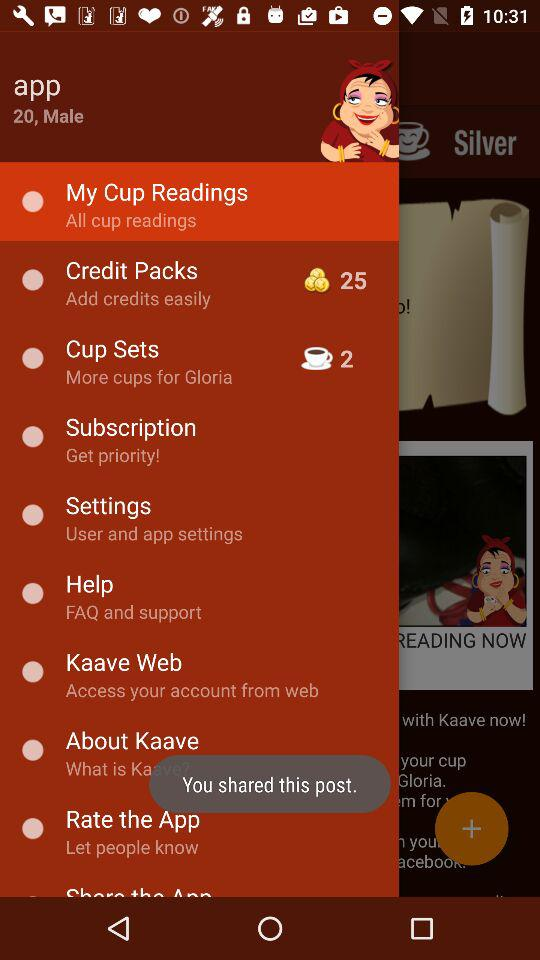What is the username? The username is "app". 